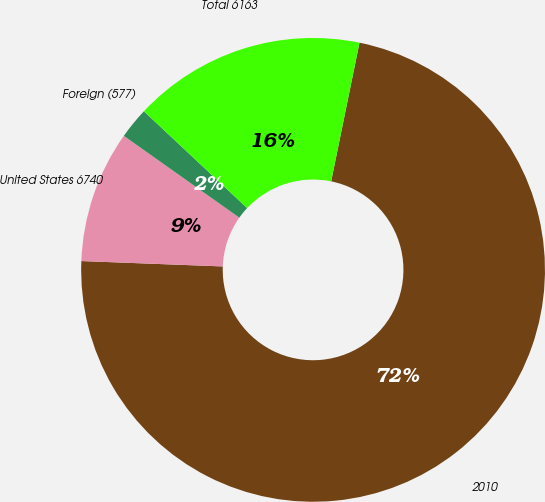<chart> <loc_0><loc_0><loc_500><loc_500><pie_chart><fcel>2010<fcel>United States 6740<fcel>Foreign (577)<fcel>Total 6163<nl><fcel>72.39%<fcel>9.2%<fcel>2.18%<fcel>16.22%<nl></chart> 